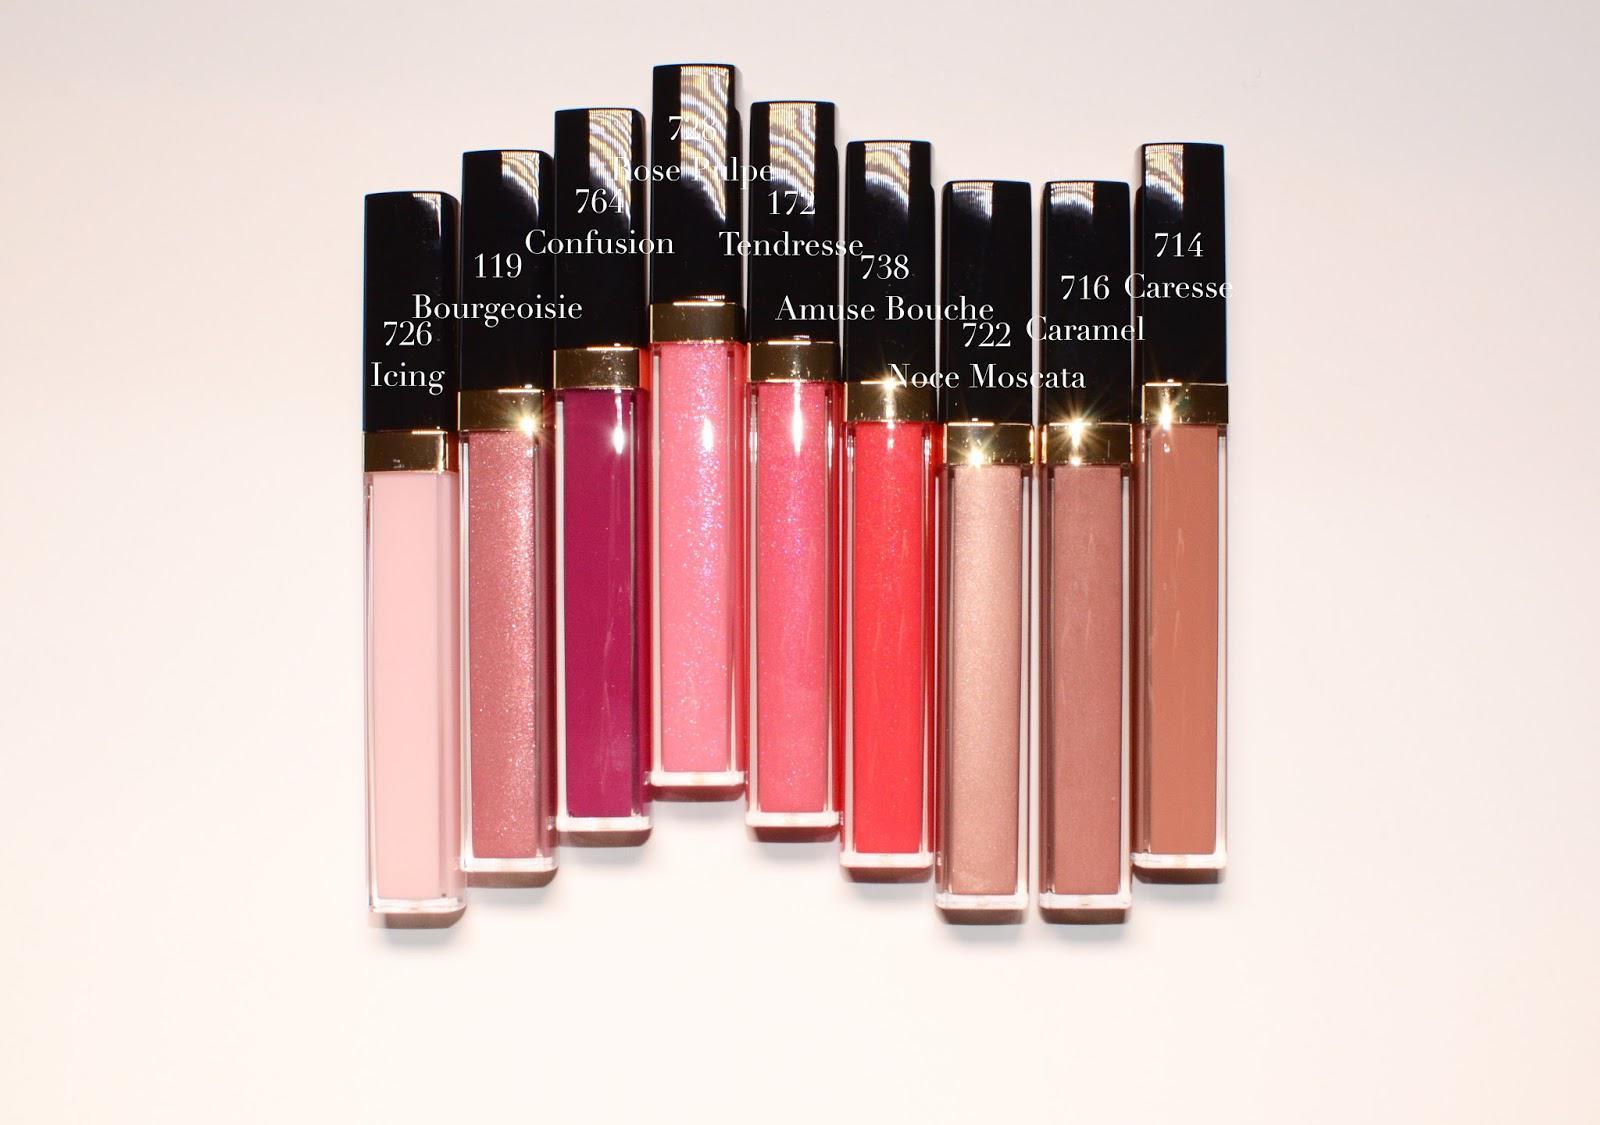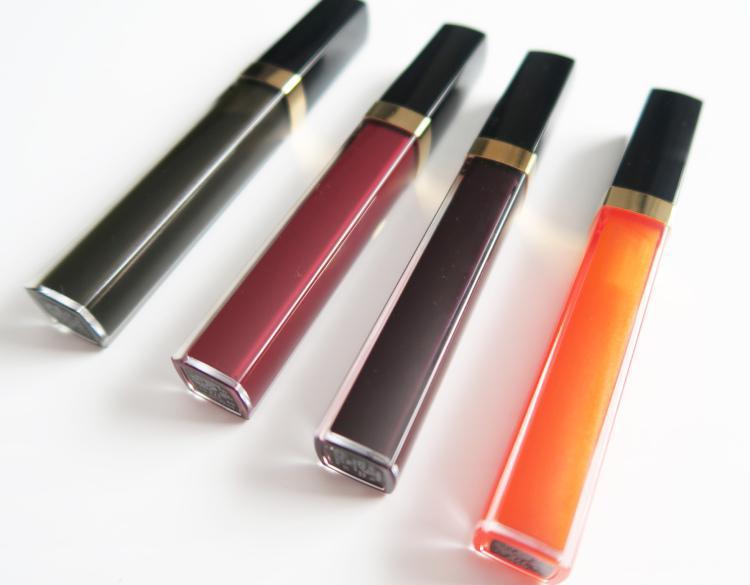The first image is the image on the left, the second image is the image on the right. For the images shown, is this caption "There are at least 8 different shades of lip gloss in their tubes." true? Answer yes or no. Yes. The first image is the image on the left, the second image is the image on the right. Examine the images to the left and right. Is the description "The left image includes at least one capped and one uncapped lipstick wand, and the right image includes at least one capped lipstick wand but no uncapped lip makeup." accurate? Answer yes or no. No. 